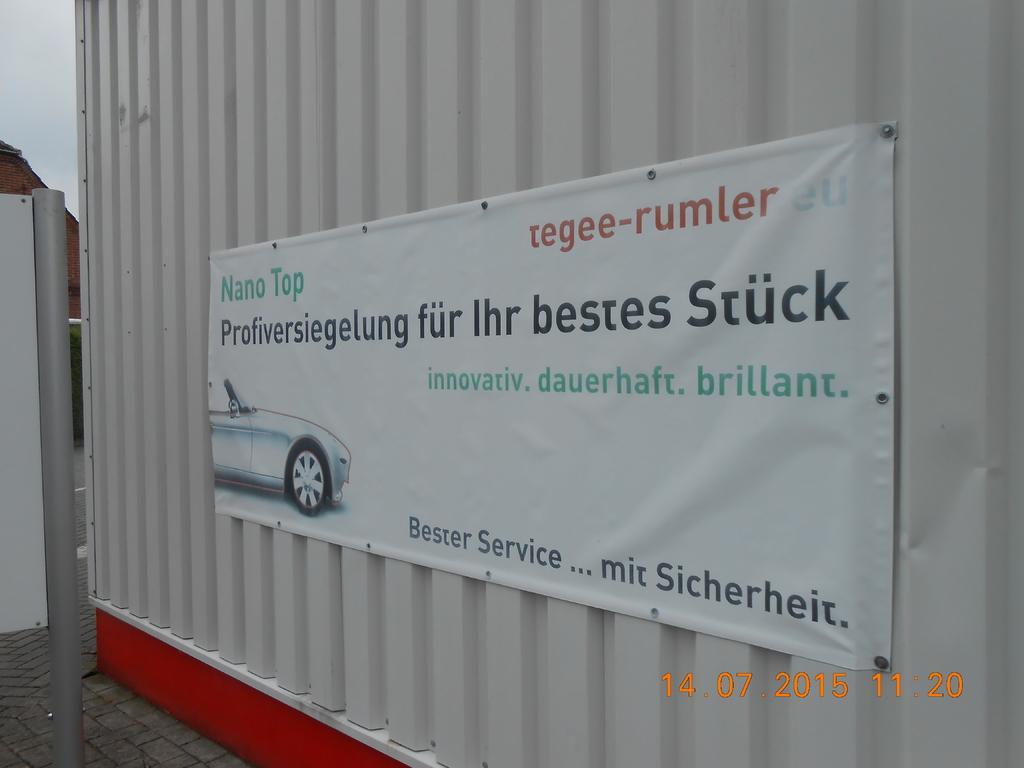Please provide a concise description of this image. In the center of the image there is a poster sticked to the container. In the background we can see sky. 